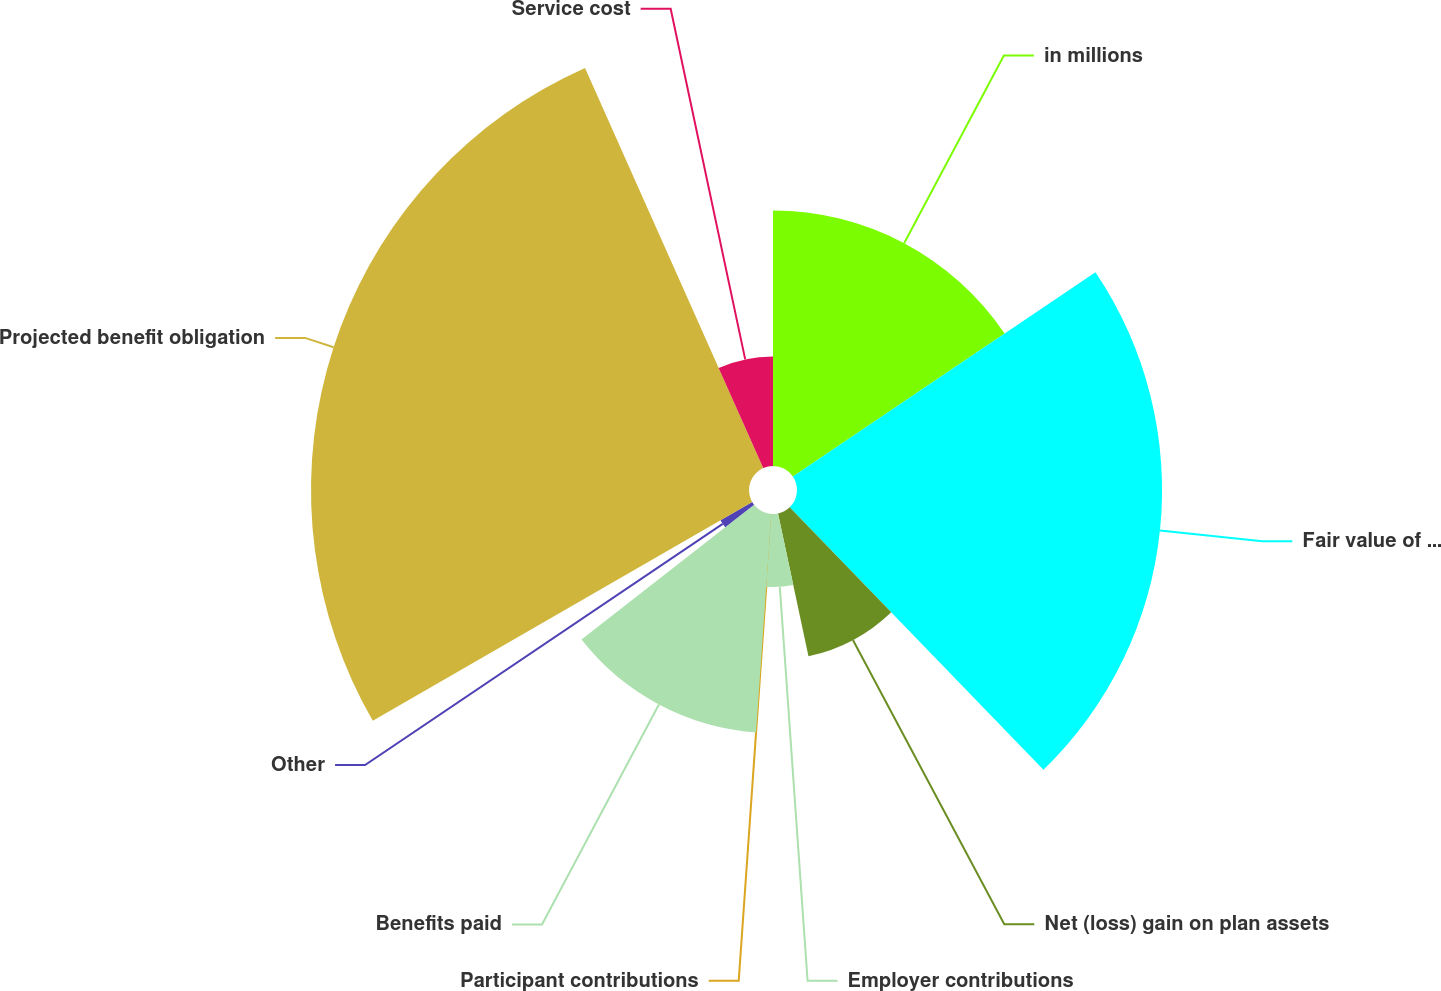<chart> <loc_0><loc_0><loc_500><loc_500><pie_chart><fcel>in millions<fcel>Fair value of plan assets at<fcel>Net (loss) gain on plan assets<fcel>Employer contributions<fcel>Participant contributions<fcel>Benefits paid<fcel>Other<fcel>Projected benefit obligation<fcel>Service cost<nl><fcel>15.55%<fcel>22.22%<fcel>8.89%<fcel>4.45%<fcel>0.01%<fcel>13.33%<fcel>2.23%<fcel>26.66%<fcel>6.67%<nl></chart> 